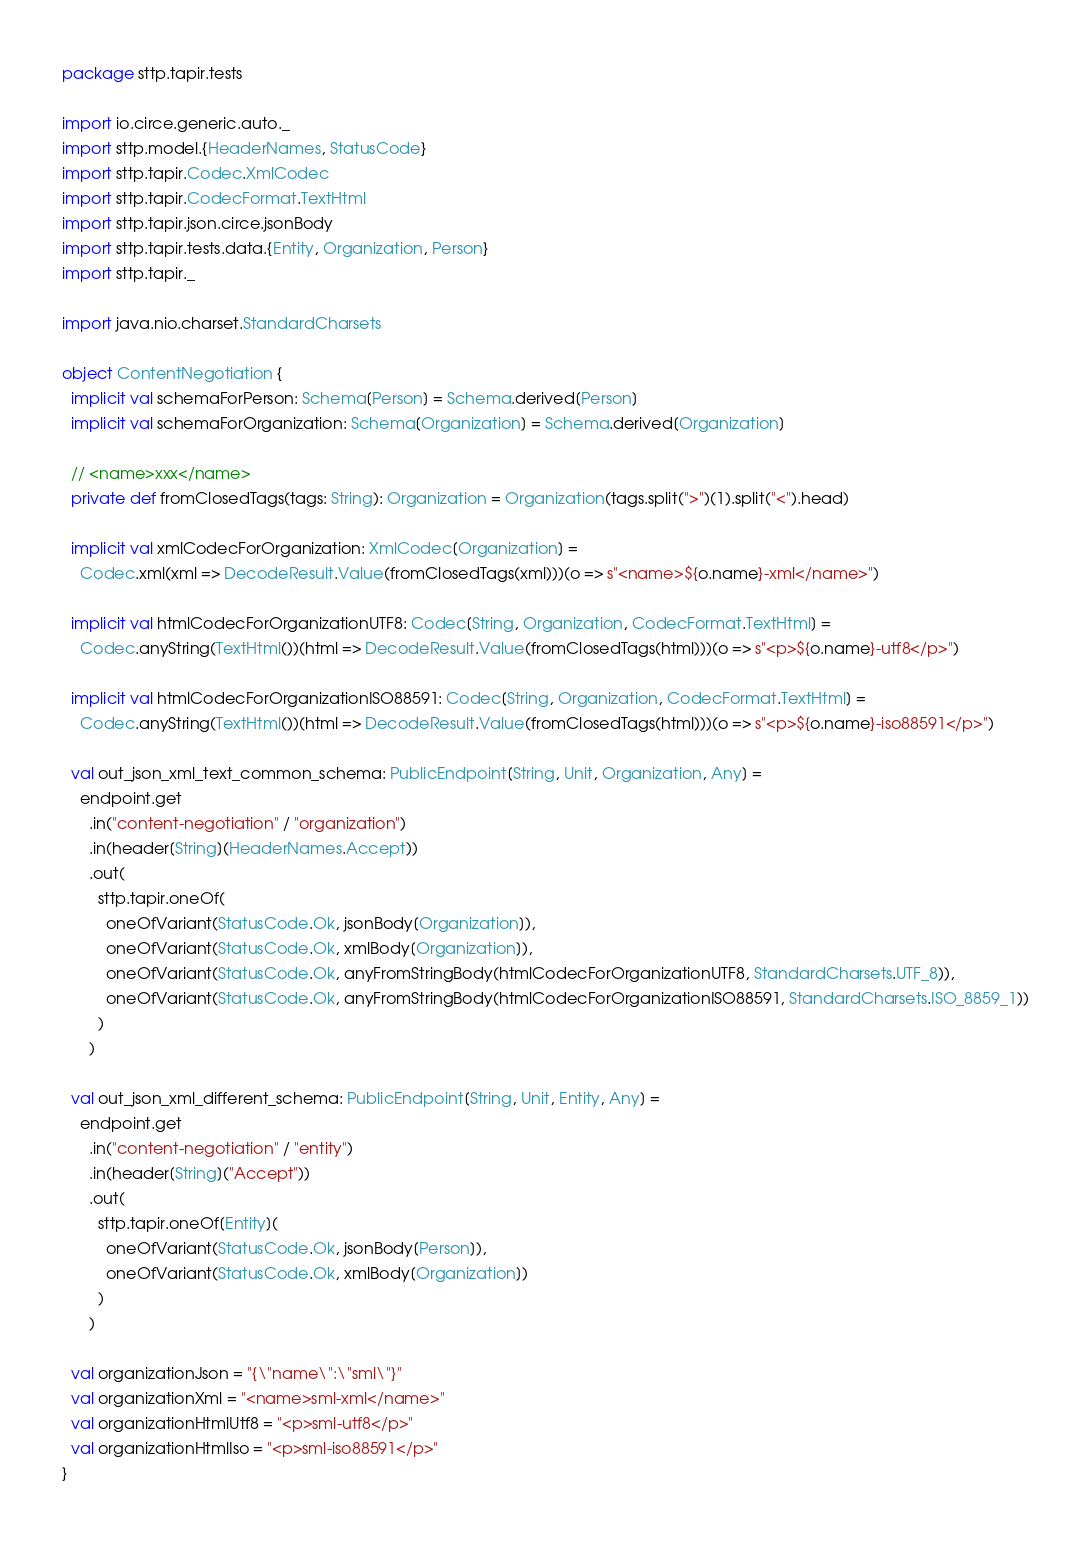Convert code to text. <code><loc_0><loc_0><loc_500><loc_500><_Scala_>package sttp.tapir.tests

import io.circe.generic.auto._
import sttp.model.{HeaderNames, StatusCode}
import sttp.tapir.Codec.XmlCodec
import sttp.tapir.CodecFormat.TextHtml
import sttp.tapir.json.circe.jsonBody
import sttp.tapir.tests.data.{Entity, Organization, Person}
import sttp.tapir._

import java.nio.charset.StandardCharsets

object ContentNegotiation {
  implicit val schemaForPerson: Schema[Person] = Schema.derived[Person]
  implicit val schemaForOrganization: Schema[Organization] = Schema.derived[Organization]

  // <name>xxx</name>
  private def fromClosedTags(tags: String): Organization = Organization(tags.split(">")(1).split("<").head)

  implicit val xmlCodecForOrganization: XmlCodec[Organization] =
    Codec.xml(xml => DecodeResult.Value(fromClosedTags(xml)))(o => s"<name>${o.name}-xml</name>")

  implicit val htmlCodecForOrganizationUTF8: Codec[String, Organization, CodecFormat.TextHtml] =
    Codec.anyString(TextHtml())(html => DecodeResult.Value(fromClosedTags(html)))(o => s"<p>${o.name}-utf8</p>")

  implicit val htmlCodecForOrganizationISO88591: Codec[String, Organization, CodecFormat.TextHtml] =
    Codec.anyString(TextHtml())(html => DecodeResult.Value(fromClosedTags(html)))(o => s"<p>${o.name}-iso88591</p>")

  val out_json_xml_text_common_schema: PublicEndpoint[String, Unit, Organization, Any] =
    endpoint.get
      .in("content-negotiation" / "organization")
      .in(header[String](HeaderNames.Accept))
      .out(
        sttp.tapir.oneOf(
          oneOfVariant(StatusCode.Ok, jsonBody[Organization]),
          oneOfVariant(StatusCode.Ok, xmlBody[Organization]),
          oneOfVariant(StatusCode.Ok, anyFromStringBody(htmlCodecForOrganizationUTF8, StandardCharsets.UTF_8)),
          oneOfVariant(StatusCode.Ok, anyFromStringBody(htmlCodecForOrganizationISO88591, StandardCharsets.ISO_8859_1))
        )
      )

  val out_json_xml_different_schema: PublicEndpoint[String, Unit, Entity, Any] =
    endpoint.get
      .in("content-negotiation" / "entity")
      .in(header[String]("Accept"))
      .out(
        sttp.tapir.oneOf[Entity](
          oneOfVariant(StatusCode.Ok, jsonBody[Person]),
          oneOfVariant(StatusCode.Ok, xmlBody[Organization])
        )
      )

  val organizationJson = "{\"name\":\"sml\"}"
  val organizationXml = "<name>sml-xml</name>"
  val organizationHtmlUtf8 = "<p>sml-utf8</p>"
  val organizationHtmlIso = "<p>sml-iso88591</p>"
}
</code> 